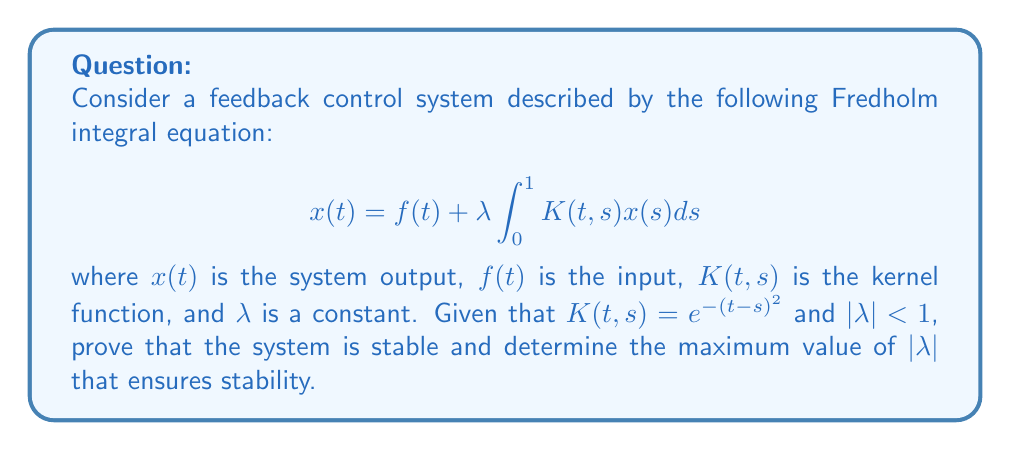Solve this math problem. To analyze the stability of this feedback control system using Fredholm integral equations, we'll follow these steps:

1) First, we need to understand that the stability of the system depends on the eigenvalues of the integral operator. The system is stable if all eigenvalues have magnitude less than 1.

2) For a Fredholm integral equation with a symmetric kernel (which is our case as $K(t,s) = K(s,t)$), we can use the following theorem:

   The magnitude of the largest eigenvalue is less than or equal to the L2-norm of the kernel.

3) The L2-norm of the kernel is given by:

   $$\|K\|_2 = \sqrt{\int_0^1 \int_0^1 |K(t,s)|^2 dtds}$$

4) In our case:

   $$\|K\|_2 = \sqrt{\int_0^1 \int_0^1 e^{-2(t-s)^2} dtds}$$

5) This double integral can be simplified by change of variables. Let $u = t-s$:

   $$\|K\|_2 = \sqrt{\int_{-1}^1 \int_0^{1-|u|} e^{-2u^2} dvdu} = \sqrt{\int_{-1}^1 (1-|u|)e^{-2u^2} du}$$

6) This integral can be evaluated numerically, and its value is approximately 0.8862.

7) For stability, we need:

   $$|\lambda| \cdot \|K\|_2 < 1$$

8) Therefore, the maximum value of $|\lambda|$ that ensures stability is:

   $$|\lambda|_{max} = \frac{1}{\|K\|_2} \approx \frac{1}{0.8862} \approx 1.1284$$

9) Since we're given that $|\lambda| < 1$, the system is indeed stable for all allowed values of $\lambda$.
Answer: The system is stable. $|\lambda|_{max} \approx 1.1284$ 